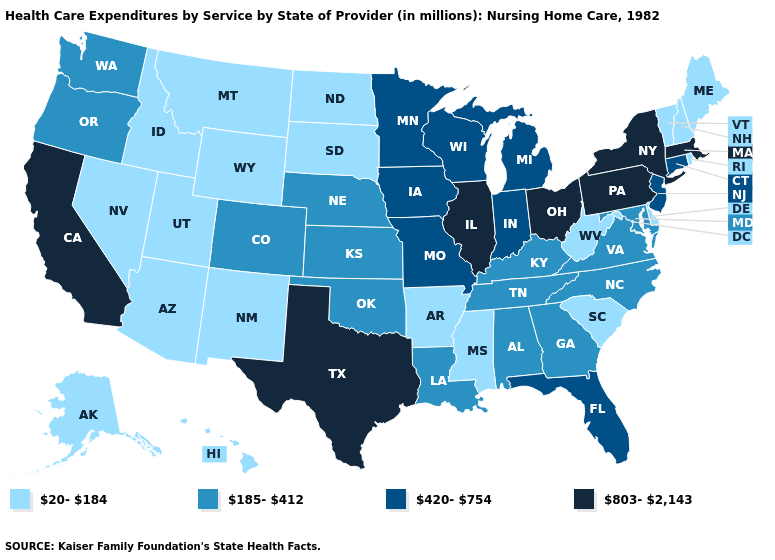Does Mississippi have the same value as Nebraska?
Keep it brief. No. What is the lowest value in the MidWest?
Quick response, please. 20-184. What is the lowest value in states that border Maryland?
Answer briefly. 20-184. Among the states that border Utah , does New Mexico have the lowest value?
Be succinct. Yes. Does the map have missing data?
Keep it brief. No. Is the legend a continuous bar?
Short answer required. No. What is the value of New Hampshire?
Concise answer only. 20-184. What is the value of Maine?
Keep it brief. 20-184. Which states have the highest value in the USA?
Answer briefly. California, Illinois, Massachusetts, New York, Ohio, Pennsylvania, Texas. Which states have the lowest value in the USA?
Answer briefly. Alaska, Arizona, Arkansas, Delaware, Hawaii, Idaho, Maine, Mississippi, Montana, Nevada, New Hampshire, New Mexico, North Dakota, Rhode Island, South Carolina, South Dakota, Utah, Vermont, West Virginia, Wyoming. Among the states that border Rhode Island , does Connecticut have the lowest value?
Write a very short answer. Yes. Name the states that have a value in the range 185-412?
Be succinct. Alabama, Colorado, Georgia, Kansas, Kentucky, Louisiana, Maryland, Nebraska, North Carolina, Oklahoma, Oregon, Tennessee, Virginia, Washington. Is the legend a continuous bar?
Answer briefly. No. What is the highest value in the Northeast ?
Give a very brief answer. 803-2,143. What is the value of Missouri?
Quick response, please. 420-754. 